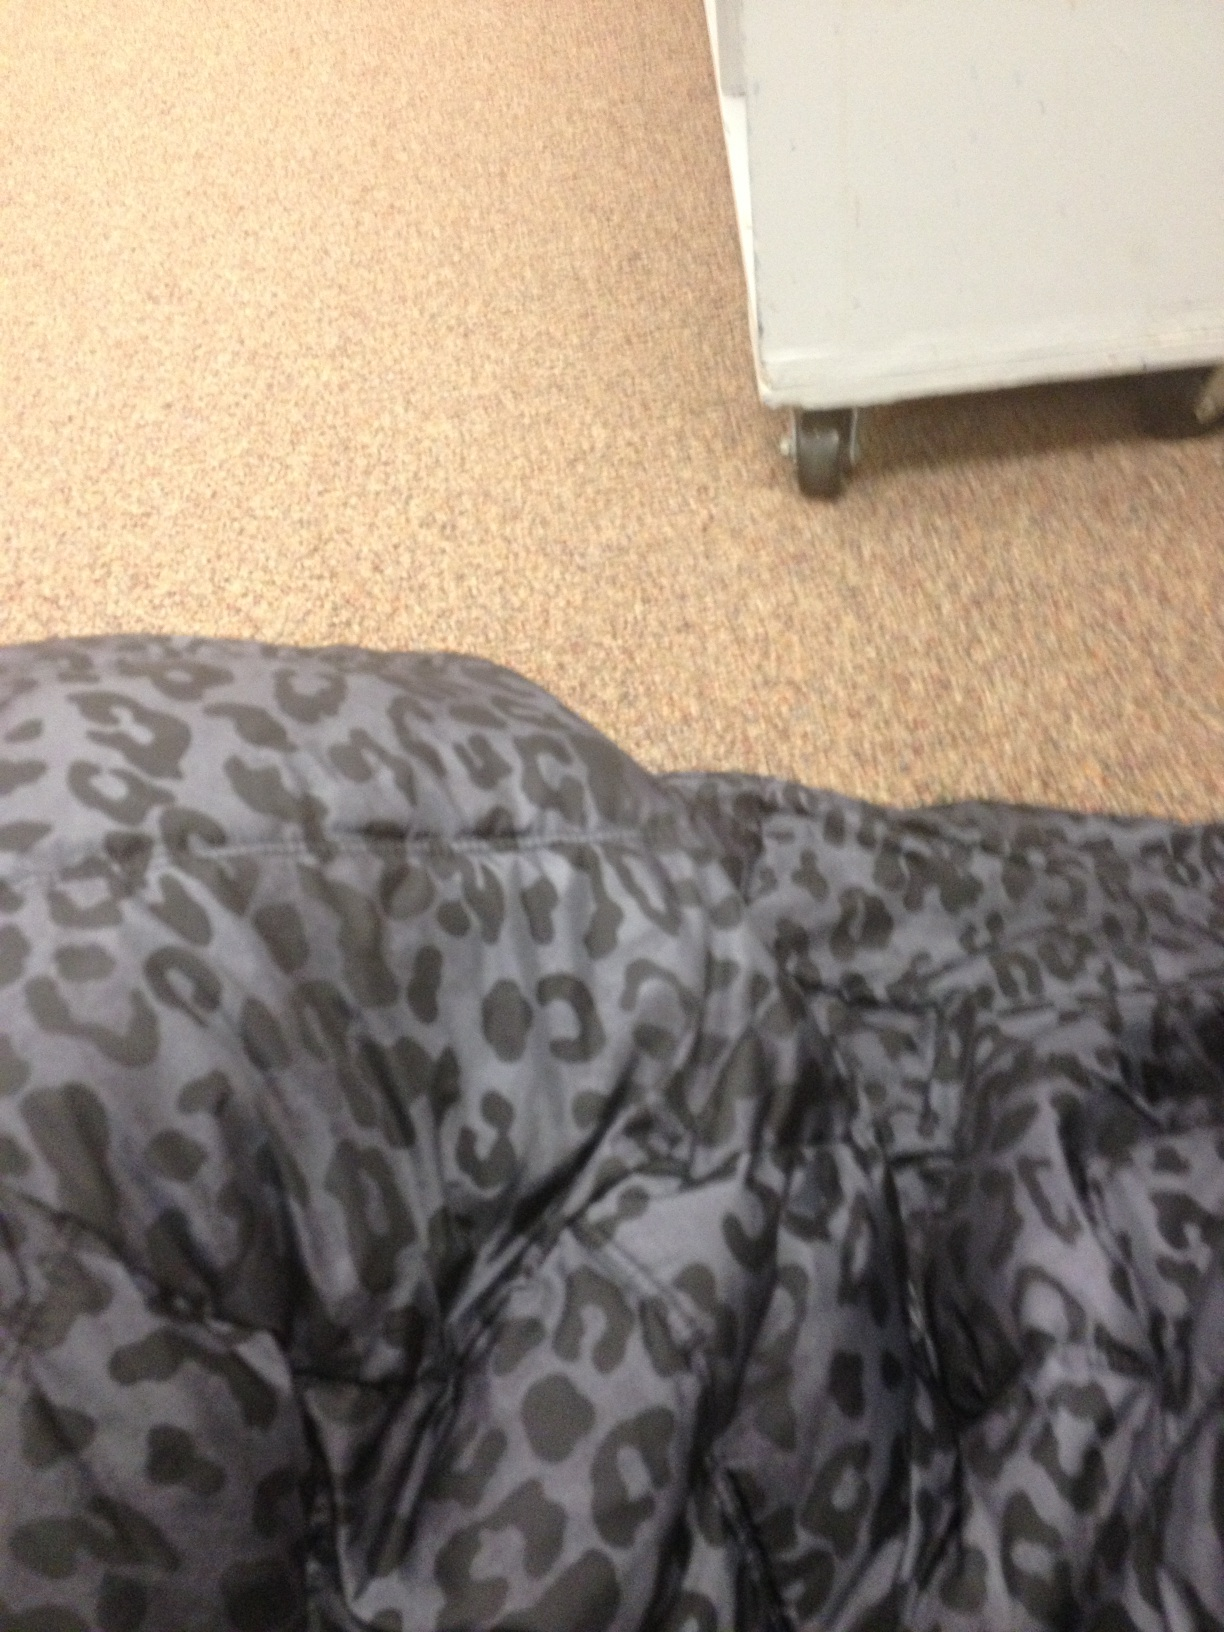Can you describe the texture of the material shown? The material appears to have a smooth texture, consistent with synthetic fabrics common in garments with printed designs like the cheetah pattern we see here. 